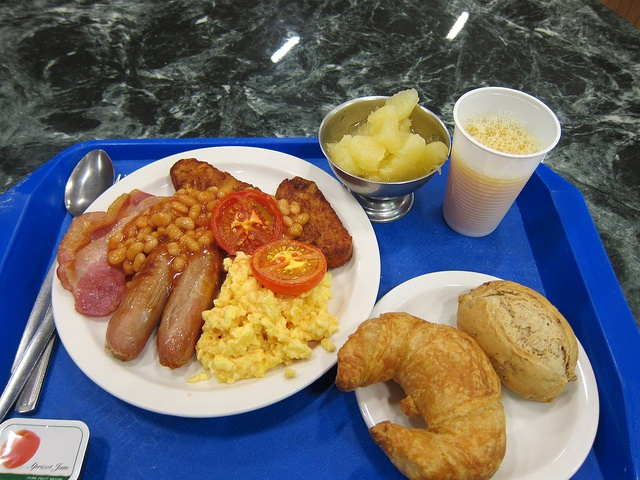Describe the objects in this image and their specific colors. I can see dining table in black, gray, and purple tones, cup in black, tan, lightgray, and darkgray tones, bowl in black, khaki, and olive tones, hot dog in black, brown, gray, tan, and maroon tones, and hot dog in black, brown, tan, and maroon tones in this image. 